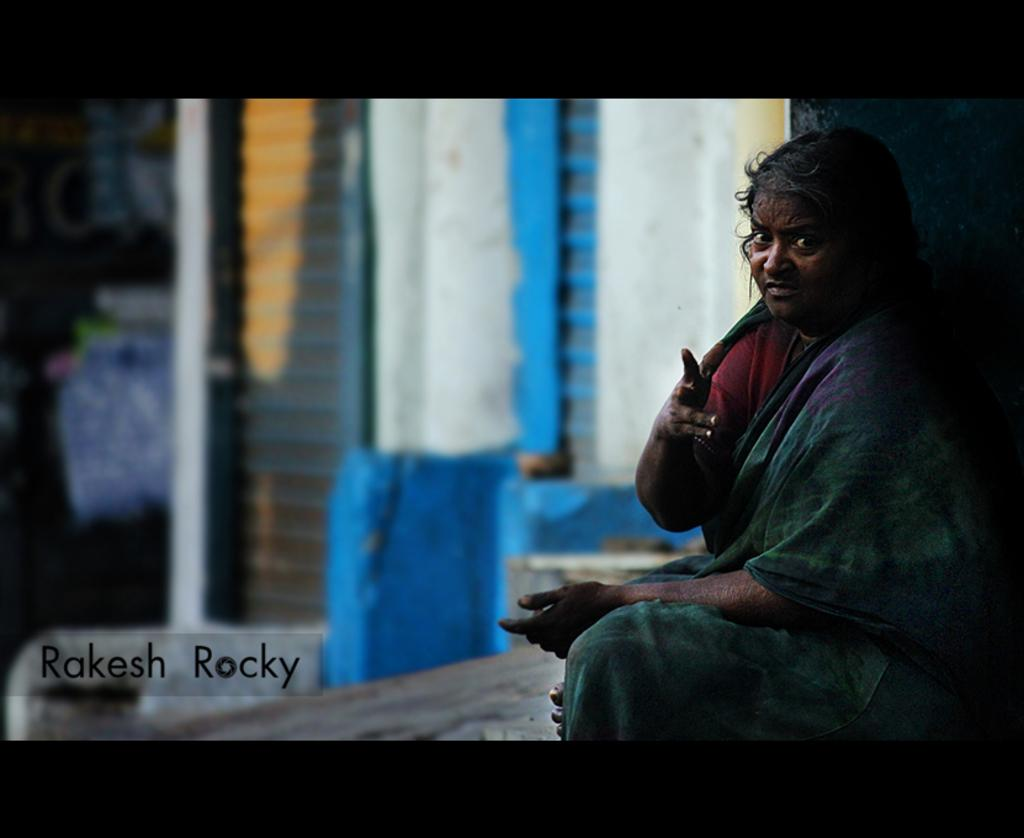What is the person in the image doing? The person is sitting in the image. What is the person wearing? The person is wearing a green saree. What can be seen behind the person in the image? There is a wall visible in the image. What colors are present on the wall? The wall has blue and white colors. Can you see the person balancing on one finger in the image? No, there is no indication that the person is balancing on one finger in the image. 